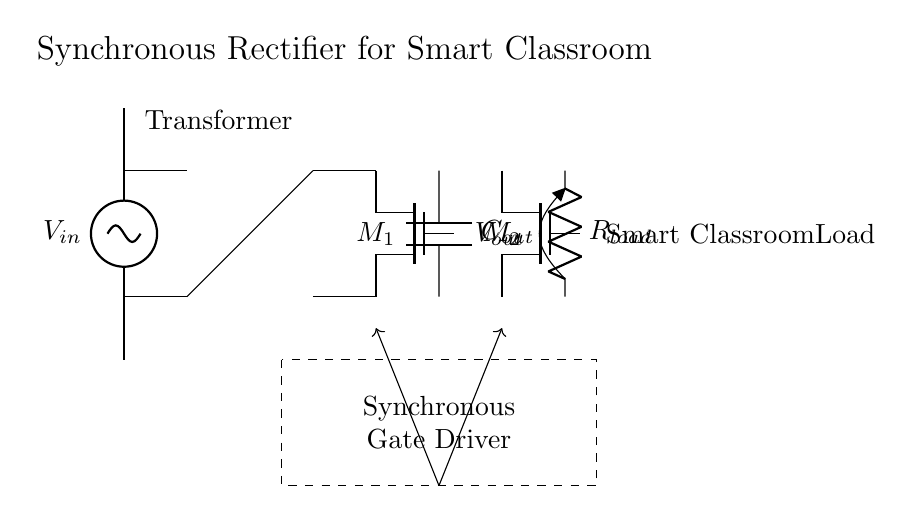What is the type of input voltage source in the circuit? The circuit shows a voltage source symbol labeled as V in, which indicates it's an alternating current (AC) voltage source.
Answer: Alternating current What are the two types of transistors shown in this synchronous rectifier circuit? The circuit contains two symbols labeled as M1 and M2, which are both n-channel MOSFETs used for synchronous rectification.
Answer: n-channel MOSFETs What is the purpose of the transformer in this circuit? The transformer in the circuit converts the input voltage level from V in to a different voltage level, regulating the voltage for later stages of power conversion.
Answer: Voltage conversion How many loads does this circuit power according to the diagram? The circuit diagram indicates one load represented by the resistor labeled R load, connected across the output.
Answer: One load What is the component labeled C out used for in the circuit? The capacitor labeled C out serves to smooth the output voltage by storing energy and reducing voltage ripple in the power converted to the load.
Answer: Smoothing output voltage How does the gate driver influence the MOSFETs in this synchronous rectifier circuit? The gate driver, indicated by the dashed rectangle, controls the switching of the MOSFETs M1 and M2 to ensure they turn on and off at the correct times for efficient operation.
Answer: Control switching What is the output voltage labeled in the diagram? The circuit notes the output voltage as V out, signifying the potential difference available at the output terminals for the load.
Answer: V out 